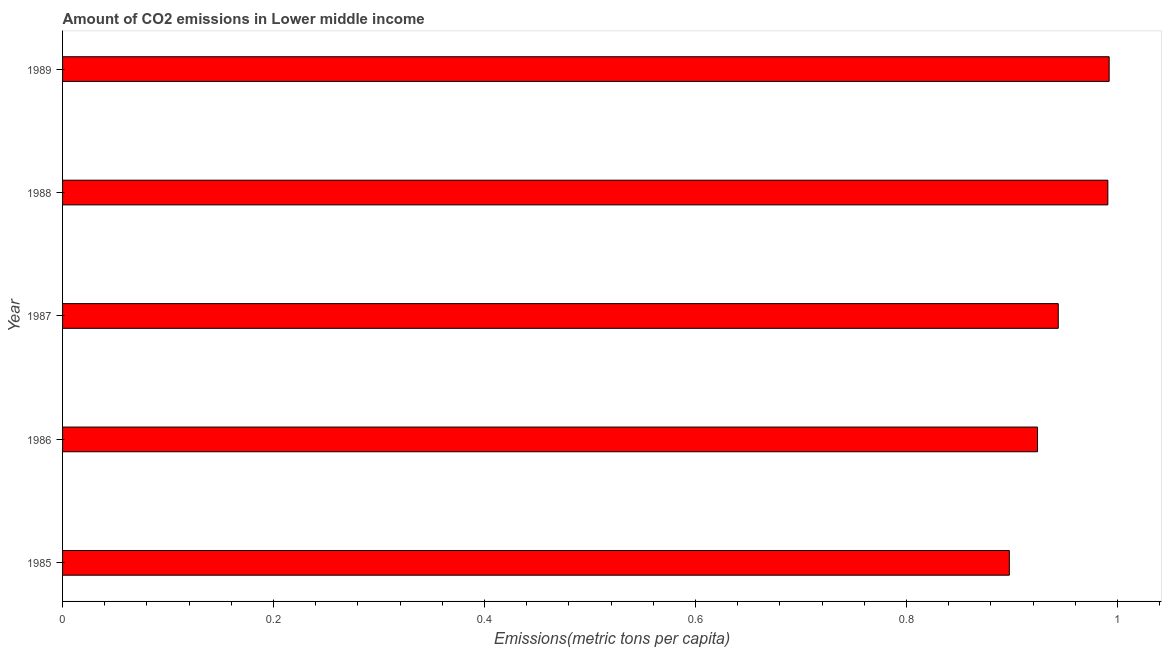Does the graph contain any zero values?
Ensure brevity in your answer.  No. Does the graph contain grids?
Your response must be concise. No. What is the title of the graph?
Give a very brief answer. Amount of CO2 emissions in Lower middle income. What is the label or title of the X-axis?
Your response must be concise. Emissions(metric tons per capita). What is the label or title of the Y-axis?
Make the answer very short. Year. What is the amount of co2 emissions in 1988?
Your answer should be very brief. 0.99. Across all years, what is the maximum amount of co2 emissions?
Your response must be concise. 0.99. Across all years, what is the minimum amount of co2 emissions?
Ensure brevity in your answer.  0.9. In which year was the amount of co2 emissions maximum?
Ensure brevity in your answer.  1989. In which year was the amount of co2 emissions minimum?
Your answer should be very brief. 1985. What is the sum of the amount of co2 emissions?
Make the answer very short. 4.75. What is the difference between the amount of co2 emissions in 1987 and 1988?
Provide a succinct answer. -0.05. What is the average amount of co2 emissions per year?
Offer a terse response. 0.95. What is the median amount of co2 emissions?
Make the answer very short. 0.94. In how many years, is the amount of co2 emissions greater than 0.44 metric tons per capita?
Provide a succinct answer. 5. What is the ratio of the amount of co2 emissions in 1985 to that in 1988?
Your answer should be very brief. 0.91. Is the amount of co2 emissions in 1985 less than that in 1986?
Your response must be concise. Yes. What is the difference between the highest and the second highest amount of co2 emissions?
Give a very brief answer. 0. Is the sum of the amount of co2 emissions in 1985 and 1989 greater than the maximum amount of co2 emissions across all years?
Your response must be concise. Yes. What is the difference between the highest and the lowest amount of co2 emissions?
Offer a terse response. 0.09. How many bars are there?
Your answer should be compact. 5. What is the Emissions(metric tons per capita) in 1985?
Provide a succinct answer. 0.9. What is the Emissions(metric tons per capita) of 1986?
Give a very brief answer. 0.92. What is the Emissions(metric tons per capita) in 1987?
Provide a succinct answer. 0.94. What is the Emissions(metric tons per capita) of 1988?
Offer a terse response. 0.99. What is the Emissions(metric tons per capita) of 1989?
Offer a terse response. 0.99. What is the difference between the Emissions(metric tons per capita) in 1985 and 1986?
Ensure brevity in your answer.  -0.03. What is the difference between the Emissions(metric tons per capita) in 1985 and 1987?
Provide a succinct answer. -0.05. What is the difference between the Emissions(metric tons per capita) in 1985 and 1988?
Provide a succinct answer. -0.09. What is the difference between the Emissions(metric tons per capita) in 1985 and 1989?
Ensure brevity in your answer.  -0.09. What is the difference between the Emissions(metric tons per capita) in 1986 and 1987?
Provide a short and direct response. -0.02. What is the difference between the Emissions(metric tons per capita) in 1986 and 1988?
Your answer should be very brief. -0.07. What is the difference between the Emissions(metric tons per capita) in 1986 and 1989?
Make the answer very short. -0.07. What is the difference between the Emissions(metric tons per capita) in 1987 and 1988?
Make the answer very short. -0.05. What is the difference between the Emissions(metric tons per capita) in 1987 and 1989?
Offer a very short reply. -0.05. What is the difference between the Emissions(metric tons per capita) in 1988 and 1989?
Ensure brevity in your answer.  -0. What is the ratio of the Emissions(metric tons per capita) in 1985 to that in 1986?
Offer a very short reply. 0.97. What is the ratio of the Emissions(metric tons per capita) in 1985 to that in 1987?
Ensure brevity in your answer.  0.95. What is the ratio of the Emissions(metric tons per capita) in 1985 to that in 1988?
Ensure brevity in your answer.  0.91. What is the ratio of the Emissions(metric tons per capita) in 1985 to that in 1989?
Your answer should be very brief. 0.91. What is the ratio of the Emissions(metric tons per capita) in 1986 to that in 1988?
Keep it short and to the point. 0.93. What is the ratio of the Emissions(metric tons per capita) in 1986 to that in 1989?
Your answer should be very brief. 0.93. What is the ratio of the Emissions(metric tons per capita) in 1987 to that in 1988?
Offer a very short reply. 0.95. What is the ratio of the Emissions(metric tons per capita) in 1987 to that in 1989?
Offer a terse response. 0.95. 